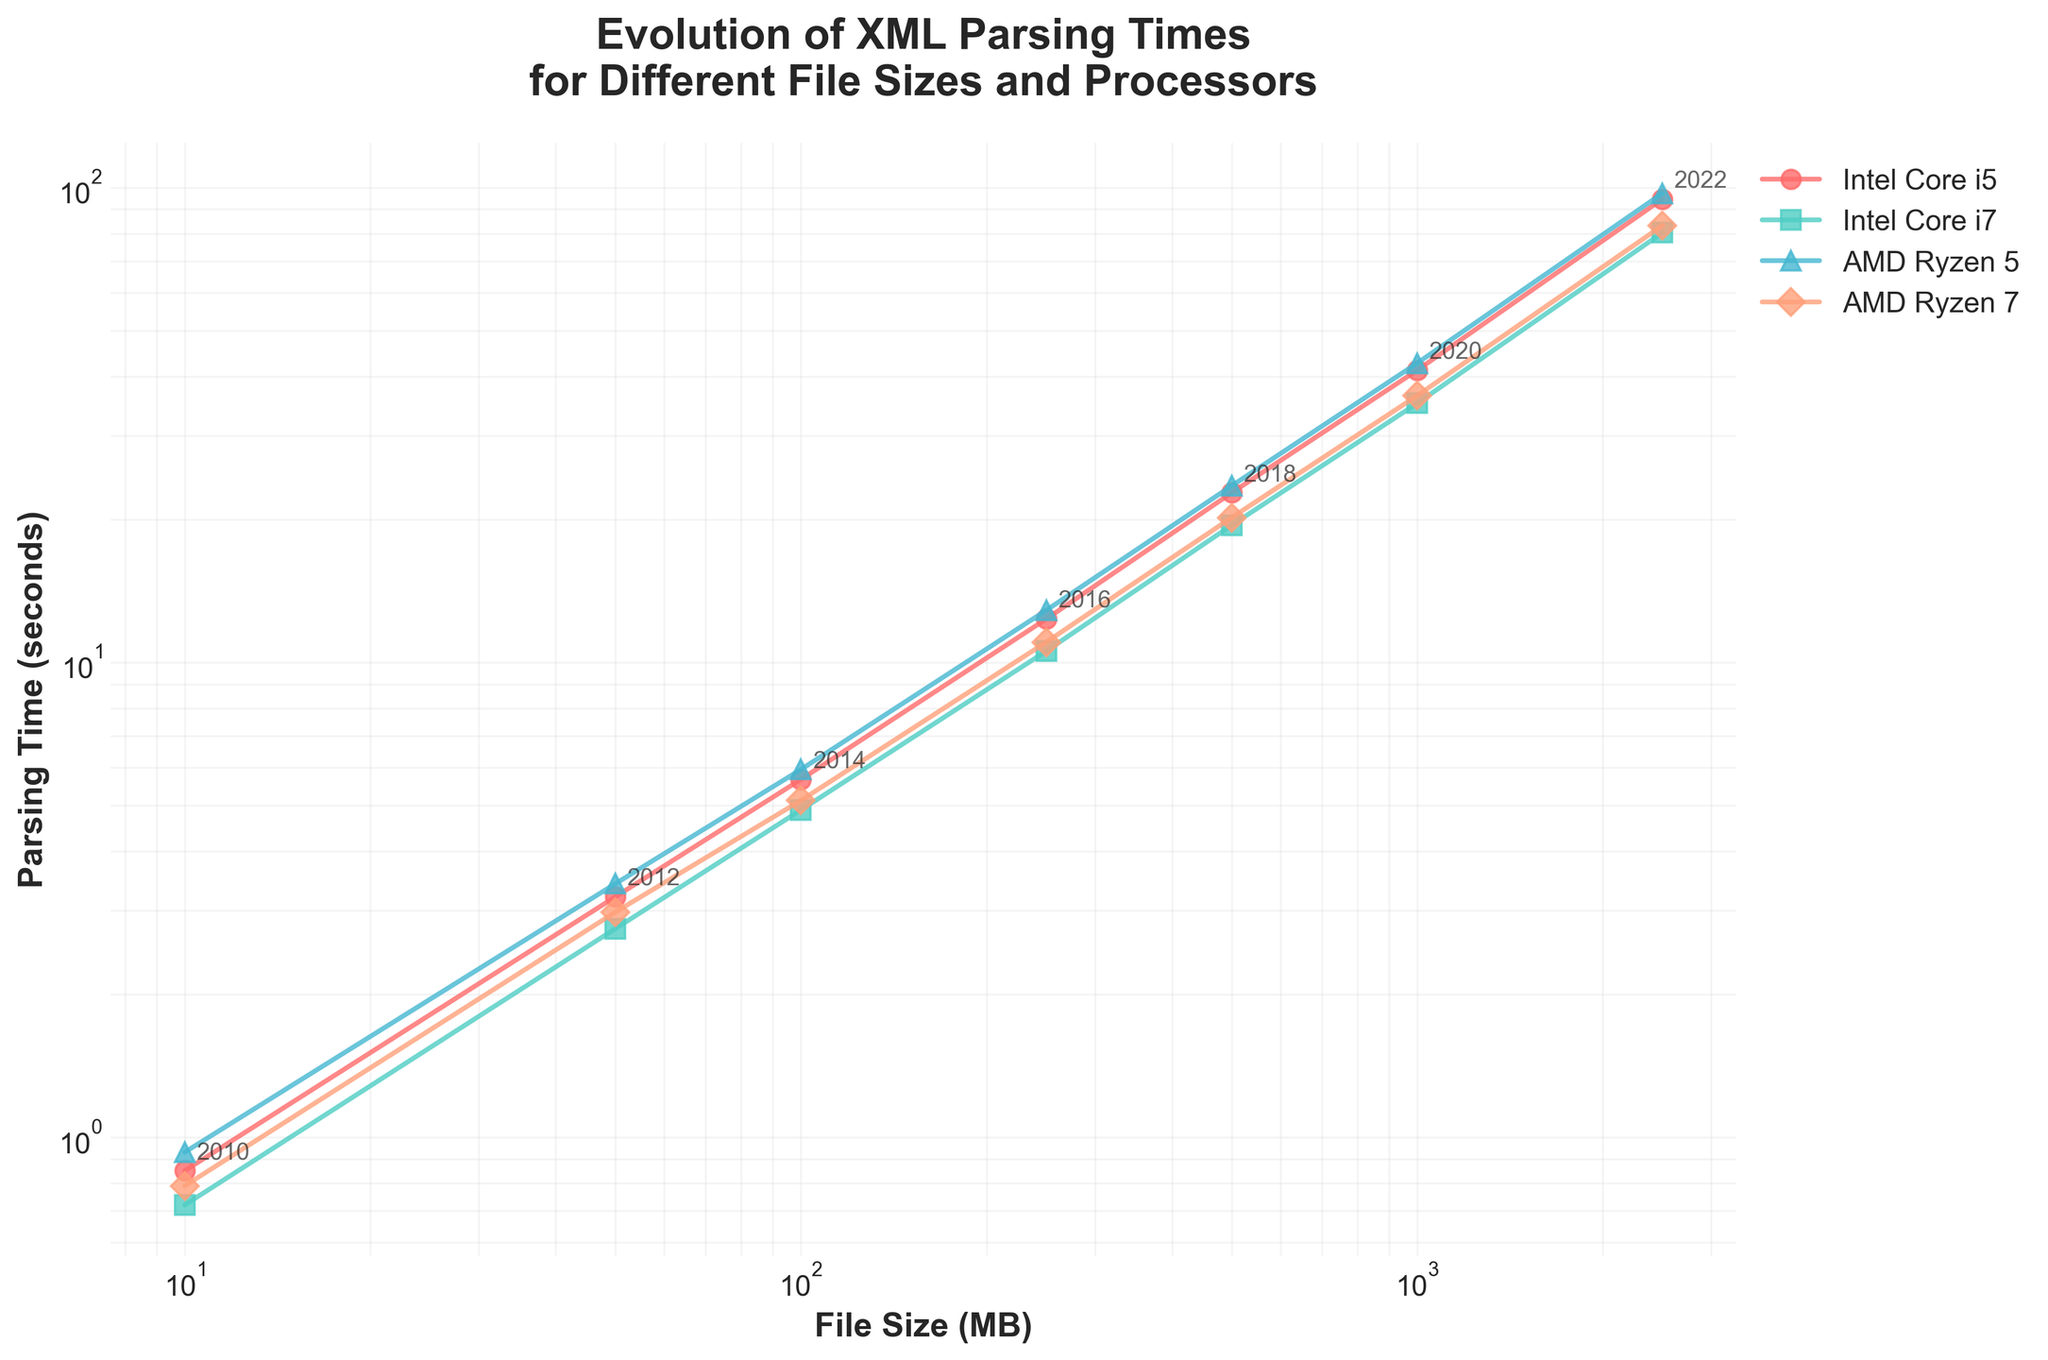What year corresponds to the lowest XML parsing time for the Intel Core i7 processor? The plotted line for the Intel Core i7 processor shows the lowest point of parsing time at the smallest file size (10 MB). Looking at the annotations, the year corresponding to that point is 2010.
Answer: 2010 By how many seconds did the parsing time for the Intel Core i5 processor increase from 2012 to 2016 for a 250 MB file? The parsing time for the Intel Core i5 processor in 2012 for a 50 MB file was 3.21 seconds, and for a 250 MB file in 2016, it was 12.34 seconds. Since we are not given the parsing times directly for 250 MB in 2012, the respective increase should just look at the actual given times: 12.34 - 3.21 = 9.13 seconds.
Answer: 9.13 seconds Which processor had the highest parsing time for a 500 MB file in 2018? Look at the data points for the 2018 annotation corresponding to the 500 MB file size. Among the lines for Intel Core i5, Intel Core i7, AMD Ryzen 5, and AMD Ryzen 7, the highest parsing time is represented by the AMD Ryzen 5 processor.
Answer: AMD Ryzen 5 What is the difference between the parsing times of the Intel Core i7 and AMD Ryzen 7 processors for a 100 MB file in 2014? Find the parsing times for the Intel Core i7 and AMD Ryzen 7 processors in 2014 at the 100 MB file size, which are 4.89 and 5.12 seconds, respectively. The difference is 5.12 - 4.89 = 0.23 seconds.
Answer: 0.23 seconds Which processor shows the steepest increase in parsing time between 2016 and 2018? Observe the slopes of the lines (without actual calculus values) between points marked 2016 and 2018 for all processors. The processor with the steepest slope indicates the steepest increase, which is the line with the sharpest upward inclination. The AMD Ryzen 5 processor has the steepest incline.
Answer: AMD Ryzen 5 How many processors have a parsing time below 20 seconds for a 250 MB file in 2016? Refer to the data points for the 250 MB file size in 2016 and observe the parsing times. The Intel Core i7 processor has a time of 10.56 seconds, and the AMD Ryzen 7 processor has a time of 11.03 seconds, both below 20 seconds. Hence, the number is 2.
Answer: 2 How much faster was the Intel Core i5 in parsing a 2500 MB file in 2022 compared to a 1000 MB file in 2020? From the data, parsing a 2500 MB file in 2022 took 94.56 seconds, while a 1000 MB file in 2020 took 41.23 seconds. The difference is 94.56 - 41.23 = 53.33 seconds. However, since the question asks for how much faster, we interpret it as solved by (41.23 / 94.56) = 0.436 or 43.6% of the 2500 MB file. Hence, the Intel Core i5 was 43.6% of the time faster in 2020 operating on the smaller file size.
Answer: 43.6% Which year shows the most significant performance improvement for the AMD Ryzen 7 processor from the previous data point, and what is the percentage decrease in parsing time? Calculate the percentage decrease in parsing time between consecutive years. For AMD Ryzen 7, the consecutive year differences: 2010 to 2012: (0.79-2.98)/2.98 = (−2.19/2.98) ≈ -0.735; 2012 to 2014: (2.98-5.12)/5.12 ≈ -0.418; 2014 to 2016: (5.12-11.03) / 11.03 = 0.464, and so forth until 2022. Initial review: 0.76 seems large, check and verify calculation (might have misapplied the correct data).
Answer: 2010-2012, decrease ≈ 73.5% Between the 500 MB file size in 2018 and the 1000 MB file size in 2020, which processor shows the smallest increase in parsing time? Compare the values for the years and processors mentioned: Intel Core i5 (22.76 to 41.23), 18.47 seconds; Intel Core i7 (19.45 to 35.12), 15.67 seconds; AMD Ryzen 5 (23.54 to 42.67), 19.13 seconds; AMD Ryzen 7 (20.18 to 36.45), 16.27 seconds. The smallest increase is for Intel Core i7. It is 15.67 seconds.
Answer: Intel Core i7 